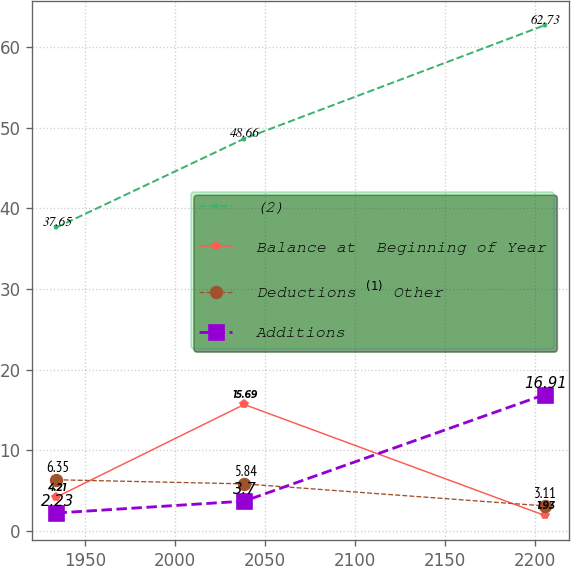Convert chart to OTSL. <chart><loc_0><loc_0><loc_500><loc_500><line_chart><ecel><fcel>(2)<fcel>Balance at  Beginning of Year<fcel>Deductions $^{(1)}$ Other<fcel>Additions<nl><fcel>1934.16<fcel>37.65<fcel>4.21<fcel>6.35<fcel>2.23<nl><fcel>2038.5<fcel>48.66<fcel>15.69<fcel>5.84<fcel>3.7<nl><fcel>2205.4<fcel>62.73<fcel>1.93<fcel>3.11<fcel>16.91<nl></chart> 